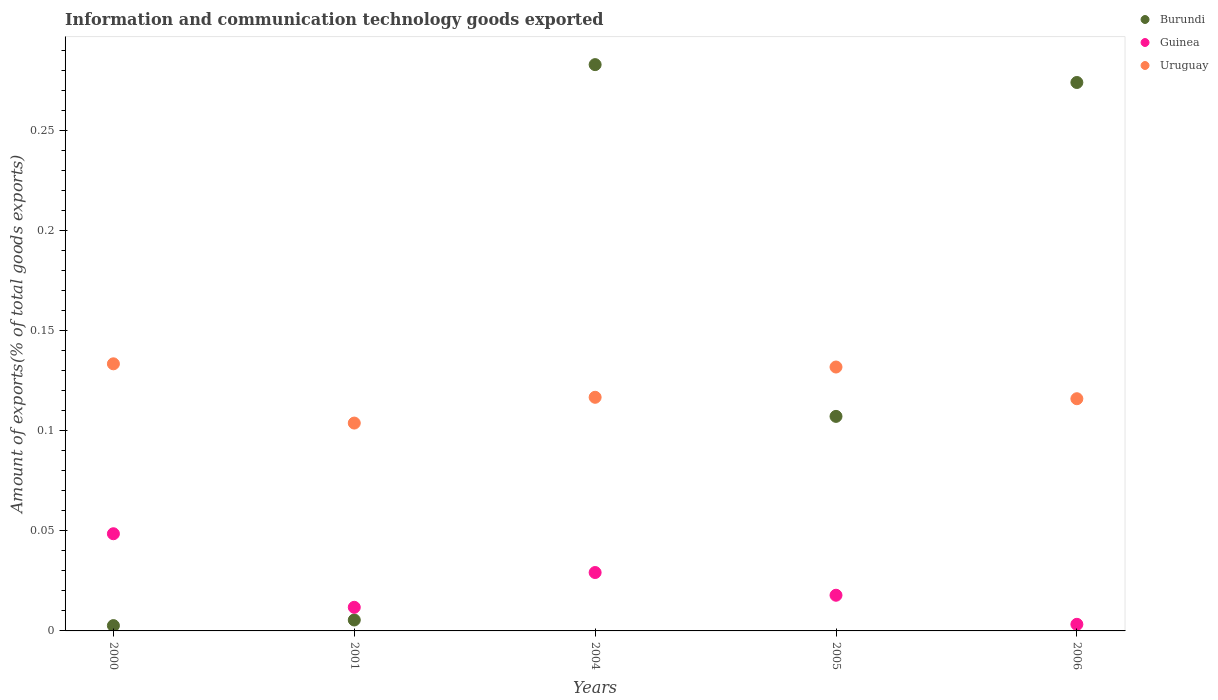How many different coloured dotlines are there?
Ensure brevity in your answer.  3. Is the number of dotlines equal to the number of legend labels?
Provide a short and direct response. Yes. What is the amount of goods exported in Burundi in 2000?
Ensure brevity in your answer.  0. Across all years, what is the maximum amount of goods exported in Uruguay?
Your answer should be compact. 0.13. Across all years, what is the minimum amount of goods exported in Burundi?
Provide a short and direct response. 0. In which year was the amount of goods exported in Guinea minimum?
Provide a succinct answer. 2006. What is the total amount of goods exported in Guinea in the graph?
Give a very brief answer. 0.11. What is the difference between the amount of goods exported in Guinea in 2000 and that in 2005?
Give a very brief answer. 0.03. What is the difference between the amount of goods exported in Guinea in 2004 and the amount of goods exported in Burundi in 2005?
Provide a short and direct response. -0.08. What is the average amount of goods exported in Uruguay per year?
Give a very brief answer. 0.12. In the year 2004, what is the difference between the amount of goods exported in Uruguay and amount of goods exported in Guinea?
Provide a succinct answer. 0.09. What is the ratio of the amount of goods exported in Guinea in 2001 to that in 2004?
Offer a terse response. 0.4. Is the amount of goods exported in Burundi in 2000 less than that in 2006?
Provide a short and direct response. Yes. Is the difference between the amount of goods exported in Uruguay in 2000 and 2005 greater than the difference between the amount of goods exported in Guinea in 2000 and 2005?
Provide a succinct answer. No. What is the difference between the highest and the second highest amount of goods exported in Uruguay?
Your answer should be compact. 0. What is the difference between the highest and the lowest amount of goods exported in Guinea?
Offer a terse response. 0.05. Is it the case that in every year, the sum of the amount of goods exported in Uruguay and amount of goods exported in Burundi  is greater than the amount of goods exported in Guinea?
Your response must be concise. Yes. Does the amount of goods exported in Uruguay monotonically increase over the years?
Provide a succinct answer. No. What is the difference between two consecutive major ticks on the Y-axis?
Offer a very short reply. 0.05. Does the graph contain any zero values?
Ensure brevity in your answer.  No. Does the graph contain grids?
Give a very brief answer. No. How are the legend labels stacked?
Give a very brief answer. Vertical. What is the title of the graph?
Ensure brevity in your answer.  Information and communication technology goods exported. What is the label or title of the X-axis?
Keep it short and to the point. Years. What is the label or title of the Y-axis?
Your answer should be compact. Amount of exports(% of total goods exports). What is the Amount of exports(% of total goods exports) in Burundi in 2000?
Your answer should be compact. 0. What is the Amount of exports(% of total goods exports) in Guinea in 2000?
Offer a terse response. 0.05. What is the Amount of exports(% of total goods exports) of Uruguay in 2000?
Keep it short and to the point. 0.13. What is the Amount of exports(% of total goods exports) of Burundi in 2001?
Your response must be concise. 0.01. What is the Amount of exports(% of total goods exports) of Guinea in 2001?
Offer a terse response. 0.01. What is the Amount of exports(% of total goods exports) in Uruguay in 2001?
Offer a very short reply. 0.1. What is the Amount of exports(% of total goods exports) of Burundi in 2004?
Provide a short and direct response. 0.28. What is the Amount of exports(% of total goods exports) in Guinea in 2004?
Your response must be concise. 0.03. What is the Amount of exports(% of total goods exports) of Uruguay in 2004?
Provide a succinct answer. 0.12. What is the Amount of exports(% of total goods exports) in Burundi in 2005?
Your response must be concise. 0.11. What is the Amount of exports(% of total goods exports) of Guinea in 2005?
Provide a short and direct response. 0.02. What is the Amount of exports(% of total goods exports) of Uruguay in 2005?
Your answer should be compact. 0.13. What is the Amount of exports(% of total goods exports) of Burundi in 2006?
Ensure brevity in your answer.  0.27. What is the Amount of exports(% of total goods exports) in Guinea in 2006?
Make the answer very short. 0. What is the Amount of exports(% of total goods exports) of Uruguay in 2006?
Provide a succinct answer. 0.12. Across all years, what is the maximum Amount of exports(% of total goods exports) in Burundi?
Your answer should be very brief. 0.28. Across all years, what is the maximum Amount of exports(% of total goods exports) in Guinea?
Your response must be concise. 0.05. Across all years, what is the maximum Amount of exports(% of total goods exports) of Uruguay?
Your response must be concise. 0.13. Across all years, what is the minimum Amount of exports(% of total goods exports) in Burundi?
Offer a terse response. 0. Across all years, what is the minimum Amount of exports(% of total goods exports) in Guinea?
Your response must be concise. 0. Across all years, what is the minimum Amount of exports(% of total goods exports) in Uruguay?
Your response must be concise. 0.1. What is the total Amount of exports(% of total goods exports) in Burundi in the graph?
Offer a terse response. 0.67. What is the total Amount of exports(% of total goods exports) in Guinea in the graph?
Your answer should be very brief. 0.11. What is the total Amount of exports(% of total goods exports) of Uruguay in the graph?
Offer a terse response. 0.6. What is the difference between the Amount of exports(% of total goods exports) of Burundi in 2000 and that in 2001?
Keep it short and to the point. -0. What is the difference between the Amount of exports(% of total goods exports) in Guinea in 2000 and that in 2001?
Provide a succinct answer. 0.04. What is the difference between the Amount of exports(% of total goods exports) of Uruguay in 2000 and that in 2001?
Your answer should be compact. 0.03. What is the difference between the Amount of exports(% of total goods exports) in Burundi in 2000 and that in 2004?
Offer a very short reply. -0.28. What is the difference between the Amount of exports(% of total goods exports) in Guinea in 2000 and that in 2004?
Your response must be concise. 0.02. What is the difference between the Amount of exports(% of total goods exports) in Uruguay in 2000 and that in 2004?
Offer a very short reply. 0.02. What is the difference between the Amount of exports(% of total goods exports) in Burundi in 2000 and that in 2005?
Provide a short and direct response. -0.1. What is the difference between the Amount of exports(% of total goods exports) in Guinea in 2000 and that in 2005?
Your answer should be very brief. 0.03. What is the difference between the Amount of exports(% of total goods exports) of Uruguay in 2000 and that in 2005?
Give a very brief answer. 0. What is the difference between the Amount of exports(% of total goods exports) of Burundi in 2000 and that in 2006?
Ensure brevity in your answer.  -0.27. What is the difference between the Amount of exports(% of total goods exports) in Guinea in 2000 and that in 2006?
Offer a very short reply. 0.05. What is the difference between the Amount of exports(% of total goods exports) in Uruguay in 2000 and that in 2006?
Give a very brief answer. 0.02. What is the difference between the Amount of exports(% of total goods exports) in Burundi in 2001 and that in 2004?
Give a very brief answer. -0.28. What is the difference between the Amount of exports(% of total goods exports) in Guinea in 2001 and that in 2004?
Your answer should be very brief. -0.02. What is the difference between the Amount of exports(% of total goods exports) of Uruguay in 2001 and that in 2004?
Keep it short and to the point. -0.01. What is the difference between the Amount of exports(% of total goods exports) of Burundi in 2001 and that in 2005?
Your answer should be compact. -0.1. What is the difference between the Amount of exports(% of total goods exports) in Guinea in 2001 and that in 2005?
Provide a short and direct response. -0.01. What is the difference between the Amount of exports(% of total goods exports) of Uruguay in 2001 and that in 2005?
Your answer should be compact. -0.03. What is the difference between the Amount of exports(% of total goods exports) in Burundi in 2001 and that in 2006?
Give a very brief answer. -0.27. What is the difference between the Amount of exports(% of total goods exports) in Guinea in 2001 and that in 2006?
Keep it short and to the point. 0.01. What is the difference between the Amount of exports(% of total goods exports) in Uruguay in 2001 and that in 2006?
Offer a very short reply. -0.01. What is the difference between the Amount of exports(% of total goods exports) in Burundi in 2004 and that in 2005?
Make the answer very short. 0.18. What is the difference between the Amount of exports(% of total goods exports) of Guinea in 2004 and that in 2005?
Keep it short and to the point. 0.01. What is the difference between the Amount of exports(% of total goods exports) in Uruguay in 2004 and that in 2005?
Offer a very short reply. -0.02. What is the difference between the Amount of exports(% of total goods exports) in Burundi in 2004 and that in 2006?
Give a very brief answer. 0.01. What is the difference between the Amount of exports(% of total goods exports) of Guinea in 2004 and that in 2006?
Your answer should be compact. 0.03. What is the difference between the Amount of exports(% of total goods exports) of Uruguay in 2004 and that in 2006?
Your answer should be compact. 0. What is the difference between the Amount of exports(% of total goods exports) in Burundi in 2005 and that in 2006?
Make the answer very short. -0.17. What is the difference between the Amount of exports(% of total goods exports) of Guinea in 2005 and that in 2006?
Make the answer very short. 0.01. What is the difference between the Amount of exports(% of total goods exports) of Uruguay in 2005 and that in 2006?
Ensure brevity in your answer.  0.02. What is the difference between the Amount of exports(% of total goods exports) of Burundi in 2000 and the Amount of exports(% of total goods exports) of Guinea in 2001?
Your response must be concise. -0.01. What is the difference between the Amount of exports(% of total goods exports) of Burundi in 2000 and the Amount of exports(% of total goods exports) of Uruguay in 2001?
Make the answer very short. -0.1. What is the difference between the Amount of exports(% of total goods exports) in Guinea in 2000 and the Amount of exports(% of total goods exports) in Uruguay in 2001?
Give a very brief answer. -0.06. What is the difference between the Amount of exports(% of total goods exports) of Burundi in 2000 and the Amount of exports(% of total goods exports) of Guinea in 2004?
Your answer should be compact. -0.03. What is the difference between the Amount of exports(% of total goods exports) of Burundi in 2000 and the Amount of exports(% of total goods exports) of Uruguay in 2004?
Ensure brevity in your answer.  -0.11. What is the difference between the Amount of exports(% of total goods exports) in Guinea in 2000 and the Amount of exports(% of total goods exports) in Uruguay in 2004?
Your answer should be very brief. -0.07. What is the difference between the Amount of exports(% of total goods exports) in Burundi in 2000 and the Amount of exports(% of total goods exports) in Guinea in 2005?
Provide a short and direct response. -0.02. What is the difference between the Amount of exports(% of total goods exports) of Burundi in 2000 and the Amount of exports(% of total goods exports) of Uruguay in 2005?
Offer a very short reply. -0.13. What is the difference between the Amount of exports(% of total goods exports) in Guinea in 2000 and the Amount of exports(% of total goods exports) in Uruguay in 2005?
Give a very brief answer. -0.08. What is the difference between the Amount of exports(% of total goods exports) of Burundi in 2000 and the Amount of exports(% of total goods exports) of Guinea in 2006?
Ensure brevity in your answer.  -0. What is the difference between the Amount of exports(% of total goods exports) in Burundi in 2000 and the Amount of exports(% of total goods exports) in Uruguay in 2006?
Provide a short and direct response. -0.11. What is the difference between the Amount of exports(% of total goods exports) of Guinea in 2000 and the Amount of exports(% of total goods exports) of Uruguay in 2006?
Make the answer very short. -0.07. What is the difference between the Amount of exports(% of total goods exports) of Burundi in 2001 and the Amount of exports(% of total goods exports) of Guinea in 2004?
Provide a succinct answer. -0.02. What is the difference between the Amount of exports(% of total goods exports) in Burundi in 2001 and the Amount of exports(% of total goods exports) in Uruguay in 2004?
Give a very brief answer. -0.11. What is the difference between the Amount of exports(% of total goods exports) in Guinea in 2001 and the Amount of exports(% of total goods exports) in Uruguay in 2004?
Your response must be concise. -0.1. What is the difference between the Amount of exports(% of total goods exports) of Burundi in 2001 and the Amount of exports(% of total goods exports) of Guinea in 2005?
Make the answer very short. -0.01. What is the difference between the Amount of exports(% of total goods exports) in Burundi in 2001 and the Amount of exports(% of total goods exports) in Uruguay in 2005?
Provide a succinct answer. -0.13. What is the difference between the Amount of exports(% of total goods exports) in Guinea in 2001 and the Amount of exports(% of total goods exports) in Uruguay in 2005?
Your response must be concise. -0.12. What is the difference between the Amount of exports(% of total goods exports) of Burundi in 2001 and the Amount of exports(% of total goods exports) of Guinea in 2006?
Provide a short and direct response. 0. What is the difference between the Amount of exports(% of total goods exports) in Burundi in 2001 and the Amount of exports(% of total goods exports) in Uruguay in 2006?
Offer a terse response. -0.11. What is the difference between the Amount of exports(% of total goods exports) of Guinea in 2001 and the Amount of exports(% of total goods exports) of Uruguay in 2006?
Give a very brief answer. -0.1. What is the difference between the Amount of exports(% of total goods exports) of Burundi in 2004 and the Amount of exports(% of total goods exports) of Guinea in 2005?
Provide a succinct answer. 0.27. What is the difference between the Amount of exports(% of total goods exports) of Burundi in 2004 and the Amount of exports(% of total goods exports) of Uruguay in 2005?
Offer a very short reply. 0.15. What is the difference between the Amount of exports(% of total goods exports) in Guinea in 2004 and the Amount of exports(% of total goods exports) in Uruguay in 2005?
Your response must be concise. -0.1. What is the difference between the Amount of exports(% of total goods exports) in Burundi in 2004 and the Amount of exports(% of total goods exports) in Guinea in 2006?
Ensure brevity in your answer.  0.28. What is the difference between the Amount of exports(% of total goods exports) of Burundi in 2004 and the Amount of exports(% of total goods exports) of Uruguay in 2006?
Provide a short and direct response. 0.17. What is the difference between the Amount of exports(% of total goods exports) in Guinea in 2004 and the Amount of exports(% of total goods exports) in Uruguay in 2006?
Give a very brief answer. -0.09. What is the difference between the Amount of exports(% of total goods exports) in Burundi in 2005 and the Amount of exports(% of total goods exports) in Guinea in 2006?
Make the answer very short. 0.1. What is the difference between the Amount of exports(% of total goods exports) of Burundi in 2005 and the Amount of exports(% of total goods exports) of Uruguay in 2006?
Give a very brief answer. -0.01. What is the difference between the Amount of exports(% of total goods exports) in Guinea in 2005 and the Amount of exports(% of total goods exports) in Uruguay in 2006?
Your answer should be very brief. -0.1. What is the average Amount of exports(% of total goods exports) in Burundi per year?
Offer a very short reply. 0.13. What is the average Amount of exports(% of total goods exports) in Guinea per year?
Make the answer very short. 0.02. What is the average Amount of exports(% of total goods exports) in Uruguay per year?
Give a very brief answer. 0.12. In the year 2000, what is the difference between the Amount of exports(% of total goods exports) of Burundi and Amount of exports(% of total goods exports) of Guinea?
Make the answer very short. -0.05. In the year 2000, what is the difference between the Amount of exports(% of total goods exports) of Burundi and Amount of exports(% of total goods exports) of Uruguay?
Your answer should be compact. -0.13. In the year 2000, what is the difference between the Amount of exports(% of total goods exports) in Guinea and Amount of exports(% of total goods exports) in Uruguay?
Offer a very short reply. -0.08. In the year 2001, what is the difference between the Amount of exports(% of total goods exports) of Burundi and Amount of exports(% of total goods exports) of Guinea?
Your response must be concise. -0.01. In the year 2001, what is the difference between the Amount of exports(% of total goods exports) of Burundi and Amount of exports(% of total goods exports) of Uruguay?
Give a very brief answer. -0.1. In the year 2001, what is the difference between the Amount of exports(% of total goods exports) in Guinea and Amount of exports(% of total goods exports) in Uruguay?
Give a very brief answer. -0.09. In the year 2004, what is the difference between the Amount of exports(% of total goods exports) of Burundi and Amount of exports(% of total goods exports) of Guinea?
Offer a terse response. 0.25. In the year 2004, what is the difference between the Amount of exports(% of total goods exports) in Burundi and Amount of exports(% of total goods exports) in Uruguay?
Your answer should be very brief. 0.17. In the year 2004, what is the difference between the Amount of exports(% of total goods exports) of Guinea and Amount of exports(% of total goods exports) of Uruguay?
Provide a short and direct response. -0.09. In the year 2005, what is the difference between the Amount of exports(% of total goods exports) of Burundi and Amount of exports(% of total goods exports) of Guinea?
Offer a terse response. 0.09. In the year 2005, what is the difference between the Amount of exports(% of total goods exports) in Burundi and Amount of exports(% of total goods exports) in Uruguay?
Offer a very short reply. -0.02. In the year 2005, what is the difference between the Amount of exports(% of total goods exports) in Guinea and Amount of exports(% of total goods exports) in Uruguay?
Offer a terse response. -0.11. In the year 2006, what is the difference between the Amount of exports(% of total goods exports) of Burundi and Amount of exports(% of total goods exports) of Guinea?
Provide a short and direct response. 0.27. In the year 2006, what is the difference between the Amount of exports(% of total goods exports) of Burundi and Amount of exports(% of total goods exports) of Uruguay?
Ensure brevity in your answer.  0.16. In the year 2006, what is the difference between the Amount of exports(% of total goods exports) in Guinea and Amount of exports(% of total goods exports) in Uruguay?
Your response must be concise. -0.11. What is the ratio of the Amount of exports(% of total goods exports) of Burundi in 2000 to that in 2001?
Provide a short and direct response. 0.48. What is the ratio of the Amount of exports(% of total goods exports) of Guinea in 2000 to that in 2001?
Provide a succinct answer. 4.12. What is the ratio of the Amount of exports(% of total goods exports) of Uruguay in 2000 to that in 2001?
Your response must be concise. 1.29. What is the ratio of the Amount of exports(% of total goods exports) of Burundi in 2000 to that in 2004?
Provide a short and direct response. 0.01. What is the ratio of the Amount of exports(% of total goods exports) in Guinea in 2000 to that in 2004?
Keep it short and to the point. 1.66. What is the ratio of the Amount of exports(% of total goods exports) in Uruguay in 2000 to that in 2004?
Provide a short and direct response. 1.14. What is the ratio of the Amount of exports(% of total goods exports) of Burundi in 2000 to that in 2005?
Your response must be concise. 0.02. What is the ratio of the Amount of exports(% of total goods exports) of Guinea in 2000 to that in 2005?
Ensure brevity in your answer.  2.72. What is the ratio of the Amount of exports(% of total goods exports) in Uruguay in 2000 to that in 2005?
Your answer should be very brief. 1.01. What is the ratio of the Amount of exports(% of total goods exports) in Burundi in 2000 to that in 2006?
Provide a short and direct response. 0.01. What is the ratio of the Amount of exports(% of total goods exports) in Guinea in 2000 to that in 2006?
Give a very brief answer. 14.72. What is the ratio of the Amount of exports(% of total goods exports) of Uruguay in 2000 to that in 2006?
Offer a terse response. 1.15. What is the ratio of the Amount of exports(% of total goods exports) of Burundi in 2001 to that in 2004?
Provide a short and direct response. 0.02. What is the ratio of the Amount of exports(% of total goods exports) in Guinea in 2001 to that in 2004?
Your response must be concise. 0.4. What is the ratio of the Amount of exports(% of total goods exports) of Uruguay in 2001 to that in 2004?
Your response must be concise. 0.89. What is the ratio of the Amount of exports(% of total goods exports) in Burundi in 2001 to that in 2005?
Offer a very short reply. 0.05. What is the ratio of the Amount of exports(% of total goods exports) in Guinea in 2001 to that in 2005?
Offer a very short reply. 0.66. What is the ratio of the Amount of exports(% of total goods exports) in Uruguay in 2001 to that in 2005?
Your answer should be very brief. 0.79. What is the ratio of the Amount of exports(% of total goods exports) in Burundi in 2001 to that in 2006?
Make the answer very short. 0.02. What is the ratio of the Amount of exports(% of total goods exports) in Guinea in 2001 to that in 2006?
Provide a succinct answer. 3.58. What is the ratio of the Amount of exports(% of total goods exports) of Uruguay in 2001 to that in 2006?
Your response must be concise. 0.9. What is the ratio of the Amount of exports(% of total goods exports) in Burundi in 2004 to that in 2005?
Your answer should be very brief. 2.64. What is the ratio of the Amount of exports(% of total goods exports) of Guinea in 2004 to that in 2005?
Offer a very short reply. 1.64. What is the ratio of the Amount of exports(% of total goods exports) of Uruguay in 2004 to that in 2005?
Offer a very short reply. 0.89. What is the ratio of the Amount of exports(% of total goods exports) of Burundi in 2004 to that in 2006?
Give a very brief answer. 1.03. What is the ratio of the Amount of exports(% of total goods exports) of Guinea in 2004 to that in 2006?
Ensure brevity in your answer.  8.85. What is the ratio of the Amount of exports(% of total goods exports) in Burundi in 2005 to that in 2006?
Make the answer very short. 0.39. What is the ratio of the Amount of exports(% of total goods exports) in Guinea in 2005 to that in 2006?
Your answer should be very brief. 5.41. What is the ratio of the Amount of exports(% of total goods exports) of Uruguay in 2005 to that in 2006?
Provide a short and direct response. 1.14. What is the difference between the highest and the second highest Amount of exports(% of total goods exports) of Burundi?
Offer a terse response. 0.01. What is the difference between the highest and the second highest Amount of exports(% of total goods exports) of Guinea?
Keep it short and to the point. 0.02. What is the difference between the highest and the second highest Amount of exports(% of total goods exports) of Uruguay?
Your response must be concise. 0. What is the difference between the highest and the lowest Amount of exports(% of total goods exports) in Burundi?
Provide a short and direct response. 0.28. What is the difference between the highest and the lowest Amount of exports(% of total goods exports) of Guinea?
Ensure brevity in your answer.  0.05. What is the difference between the highest and the lowest Amount of exports(% of total goods exports) of Uruguay?
Offer a very short reply. 0.03. 